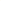<chart> <loc_0><loc_0><loc_500><loc_500><pie_chart><fcel>Unrealized gains in other<fcel>Unrealized losses in other<fcel>Net unrealized derivative<nl><fcel>0.39%<fcel>52.18%<fcel>47.43%<nl></chart> 